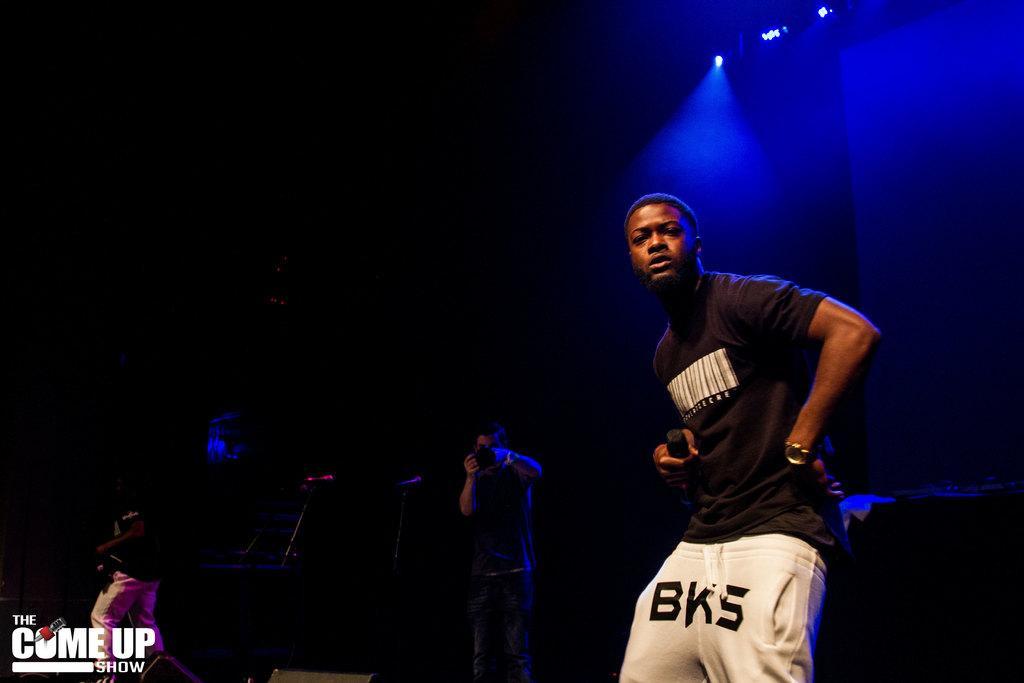Please provide a concise description of this image. In the foreground of the image there is a person wearing black color t-shirt. In the background of the image there is a person holding a camera in his hand. To the right side top of the image there are lights. 